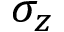<formula> <loc_0><loc_0><loc_500><loc_500>\sigma _ { z }</formula> 